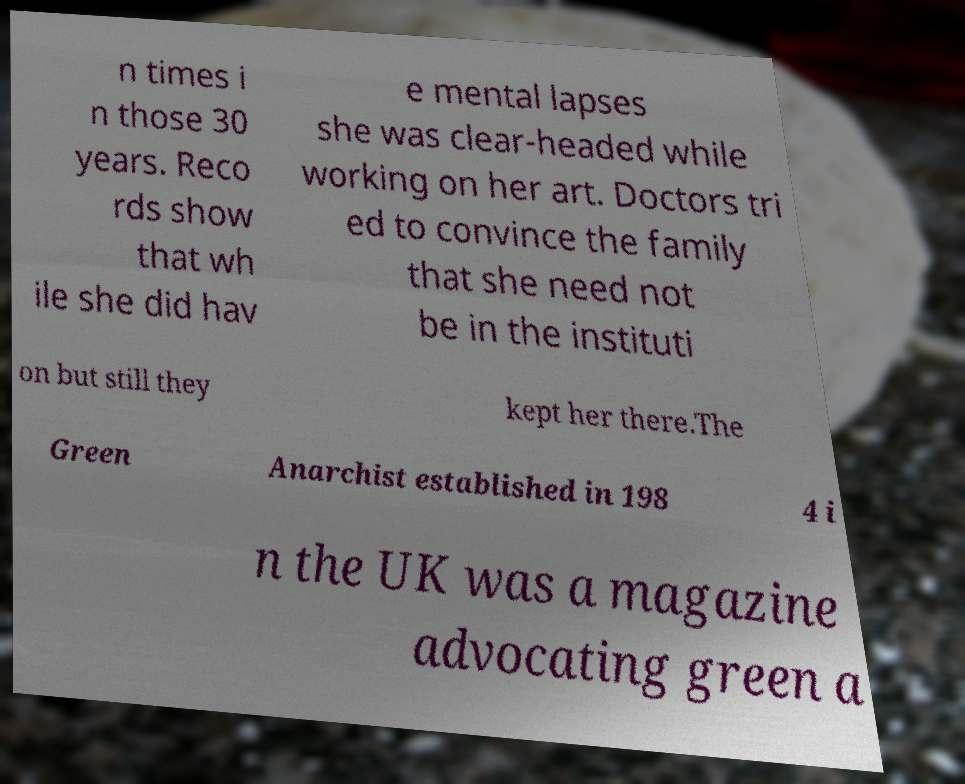Can you accurately transcribe the text from the provided image for me? n times i n those 30 years. Reco rds show that wh ile she did hav e mental lapses she was clear-headed while working on her art. Doctors tri ed to convince the family that she need not be in the instituti on but still they kept her there.The Green Anarchist established in 198 4 i n the UK was a magazine advocating green a 